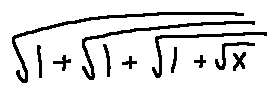<formula> <loc_0><loc_0><loc_500><loc_500>\sqrt { 1 + \sqrt { 1 + \sqrt { 1 + \sqrt { x } } } }</formula> 